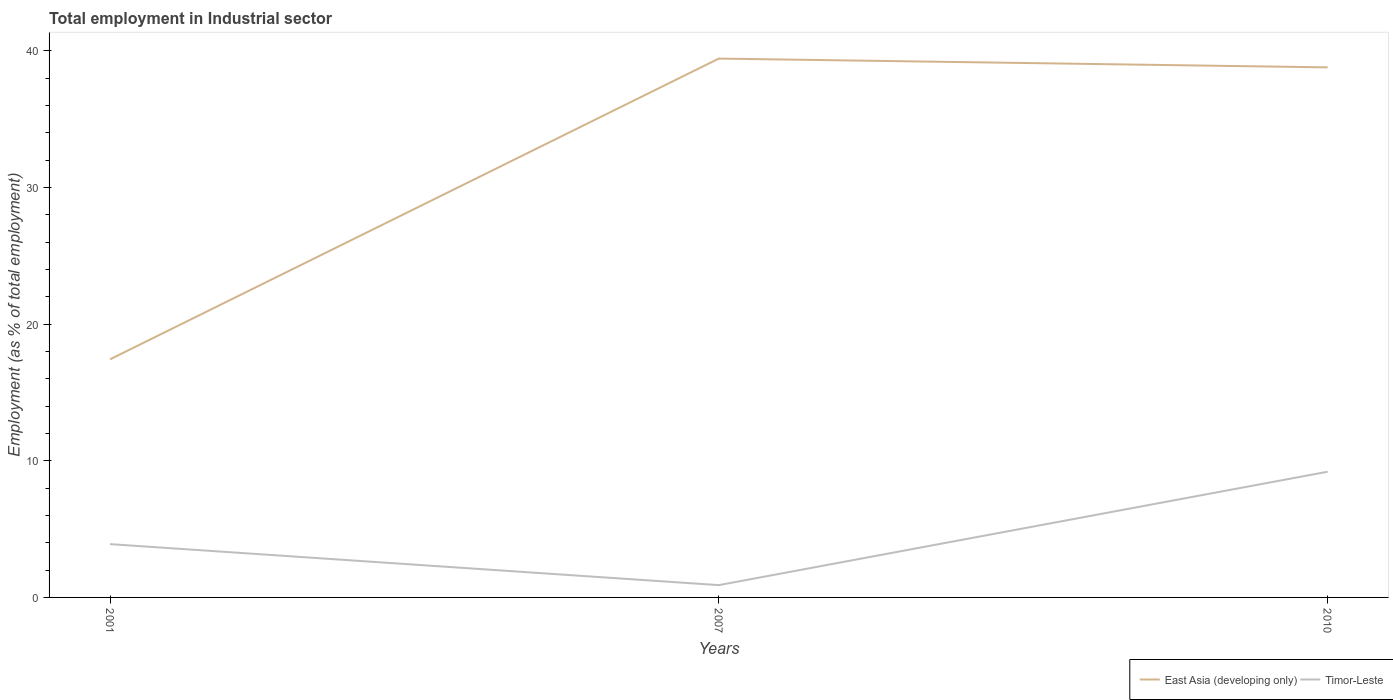Is the number of lines equal to the number of legend labels?
Provide a short and direct response. Yes. Across all years, what is the maximum employment in industrial sector in Timor-Leste?
Your answer should be very brief. 0.9. In which year was the employment in industrial sector in East Asia (developing only) maximum?
Provide a short and direct response. 2001. What is the total employment in industrial sector in Timor-Leste in the graph?
Your answer should be compact. -5.3. What is the difference between the highest and the second highest employment in industrial sector in Timor-Leste?
Your response must be concise. 8.3. What is the difference between the highest and the lowest employment in industrial sector in Timor-Leste?
Ensure brevity in your answer.  1. How many years are there in the graph?
Offer a very short reply. 3. Does the graph contain grids?
Offer a terse response. No. Where does the legend appear in the graph?
Offer a terse response. Bottom right. How many legend labels are there?
Your response must be concise. 2. What is the title of the graph?
Give a very brief answer. Total employment in Industrial sector. Does "Burundi" appear as one of the legend labels in the graph?
Your response must be concise. No. What is the label or title of the X-axis?
Offer a terse response. Years. What is the label or title of the Y-axis?
Your answer should be very brief. Employment (as % of total employment). What is the Employment (as % of total employment) in East Asia (developing only) in 2001?
Ensure brevity in your answer.  17.42. What is the Employment (as % of total employment) in Timor-Leste in 2001?
Provide a succinct answer. 3.9. What is the Employment (as % of total employment) in East Asia (developing only) in 2007?
Offer a terse response. 39.43. What is the Employment (as % of total employment) of Timor-Leste in 2007?
Provide a short and direct response. 0.9. What is the Employment (as % of total employment) in East Asia (developing only) in 2010?
Make the answer very short. 38.79. What is the Employment (as % of total employment) in Timor-Leste in 2010?
Make the answer very short. 9.2. Across all years, what is the maximum Employment (as % of total employment) in East Asia (developing only)?
Your answer should be very brief. 39.43. Across all years, what is the maximum Employment (as % of total employment) of Timor-Leste?
Provide a short and direct response. 9.2. Across all years, what is the minimum Employment (as % of total employment) of East Asia (developing only)?
Give a very brief answer. 17.42. Across all years, what is the minimum Employment (as % of total employment) of Timor-Leste?
Make the answer very short. 0.9. What is the total Employment (as % of total employment) of East Asia (developing only) in the graph?
Make the answer very short. 95.65. What is the difference between the Employment (as % of total employment) of East Asia (developing only) in 2001 and that in 2007?
Offer a terse response. -22.01. What is the difference between the Employment (as % of total employment) of Timor-Leste in 2001 and that in 2007?
Your answer should be very brief. 3. What is the difference between the Employment (as % of total employment) in East Asia (developing only) in 2001 and that in 2010?
Offer a very short reply. -21.37. What is the difference between the Employment (as % of total employment) of Timor-Leste in 2001 and that in 2010?
Your answer should be compact. -5.3. What is the difference between the Employment (as % of total employment) in East Asia (developing only) in 2007 and that in 2010?
Your answer should be compact. 0.64. What is the difference between the Employment (as % of total employment) in Timor-Leste in 2007 and that in 2010?
Provide a short and direct response. -8.3. What is the difference between the Employment (as % of total employment) in East Asia (developing only) in 2001 and the Employment (as % of total employment) in Timor-Leste in 2007?
Your answer should be compact. 16.52. What is the difference between the Employment (as % of total employment) in East Asia (developing only) in 2001 and the Employment (as % of total employment) in Timor-Leste in 2010?
Provide a succinct answer. 8.22. What is the difference between the Employment (as % of total employment) in East Asia (developing only) in 2007 and the Employment (as % of total employment) in Timor-Leste in 2010?
Offer a very short reply. 30.23. What is the average Employment (as % of total employment) in East Asia (developing only) per year?
Provide a short and direct response. 31.88. What is the average Employment (as % of total employment) of Timor-Leste per year?
Offer a very short reply. 4.67. In the year 2001, what is the difference between the Employment (as % of total employment) of East Asia (developing only) and Employment (as % of total employment) of Timor-Leste?
Your response must be concise. 13.52. In the year 2007, what is the difference between the Employment (as % of total employment) in East Asia (developing only) and Employment (as % of total employment) in Timor-Leste?
Keep it short and to the point. 38.53. In the year 2010, what is the difference between the Employment (as % of total employment) in East Asia (developing only) and Employment (as % of total employment) in Timor-Leste?
Provide a short and direct response. 29.59. What is the ratio of the Employment (as % of total employment) of East Asia (developing only) in 2001 to that in 2007?
Offer a terse response. 0.44. What is the ratio of the Employment (as % of total employment) in Timor-Leste in 2001 to that in 2007?
Your answer should be very brief. 4.33. What is the ratio of the Employment (as % of total employment) of East Asia (developing only) in 2001 to that in 2010?
Make the answer very short. 0.45. What is the ratio of the Employment (as % of total employment) of Timor-Leste in 2001 to that in 2010?
Provide a succinct answer. 0.42. What is the ratio of the Employment (as % of total employment) in East Asia (developing only) in 2007 to that in 2010?
Your answer should be very brief. 1.02. What is the ratio of the Employment (as % of total employment) in Timor-Leste in 2007 to that in 2010?
Offer a very short reply. 0.1. What is the difference between the highest and the second highest Employment (as % of total employment) of East Asia (developing only)?
Your answer should be very brief. 0.64. What is the difference between the highest and the lowest Employment (as % of total employment) in East Asia (developing only)?
Keep it short and to the point. 22.01. What is the difference between the highest and the lowest Employment (as % of total employment) in Timor-Leste?
Your answer should be very brief. 8.3. 